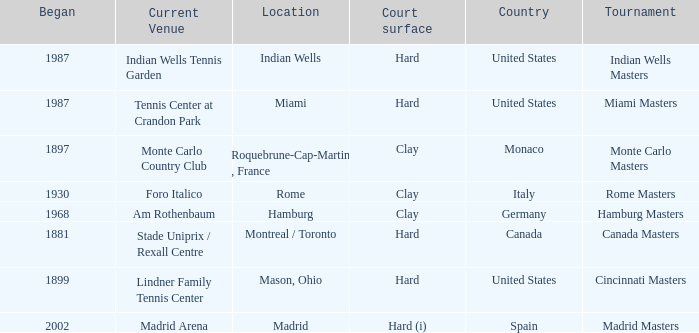Could you parse the entire table as a dict? {'header': ['Began', 'Current Venue', 'Location', 'Court surface', 'Country', 'Tournament'], 'rows': [['1987', 'Indian Wells Tennis Garden', 'Indian Wells', 'Hard', 'United States', 'Indian Wells Masters'], ['1987', 'Tennis Center at Crandon Park', 'Miami', 'Hard', 'United States', 'Miami Masters'], ['1897', 'Monte Carlo Country Club', 'Roquebrune-Cap-Martin , France', 'Clay', 'Monaco', 'Monte Carlo Masters'], ['1930', 'Foro Italico', 'Rome', 'Clay', 'Italy', 'Rome Masters'], ['1968', 'Am Rothenbaum', 'Hamburg', 'Clay', 'Germany', 'Hamburg Masters'], ['1881', 'Stade Uniprix / Rexall Centre', 'Montreal / Toronto', 'Hard', 'Canada', 'Canada Masters'], ['1899', 'Lindner Family Tennis Center', 'Mason, Ohio', 'Hard', 'United States', 'Cincinnati Masters'], ['2002', 'Madrid Arena', 'Madrid', 'Hard (i)', 'Spain', 'Madrid Masters']]} Which tournaments current venue is the Madrid Arena? Madrid Masters. 